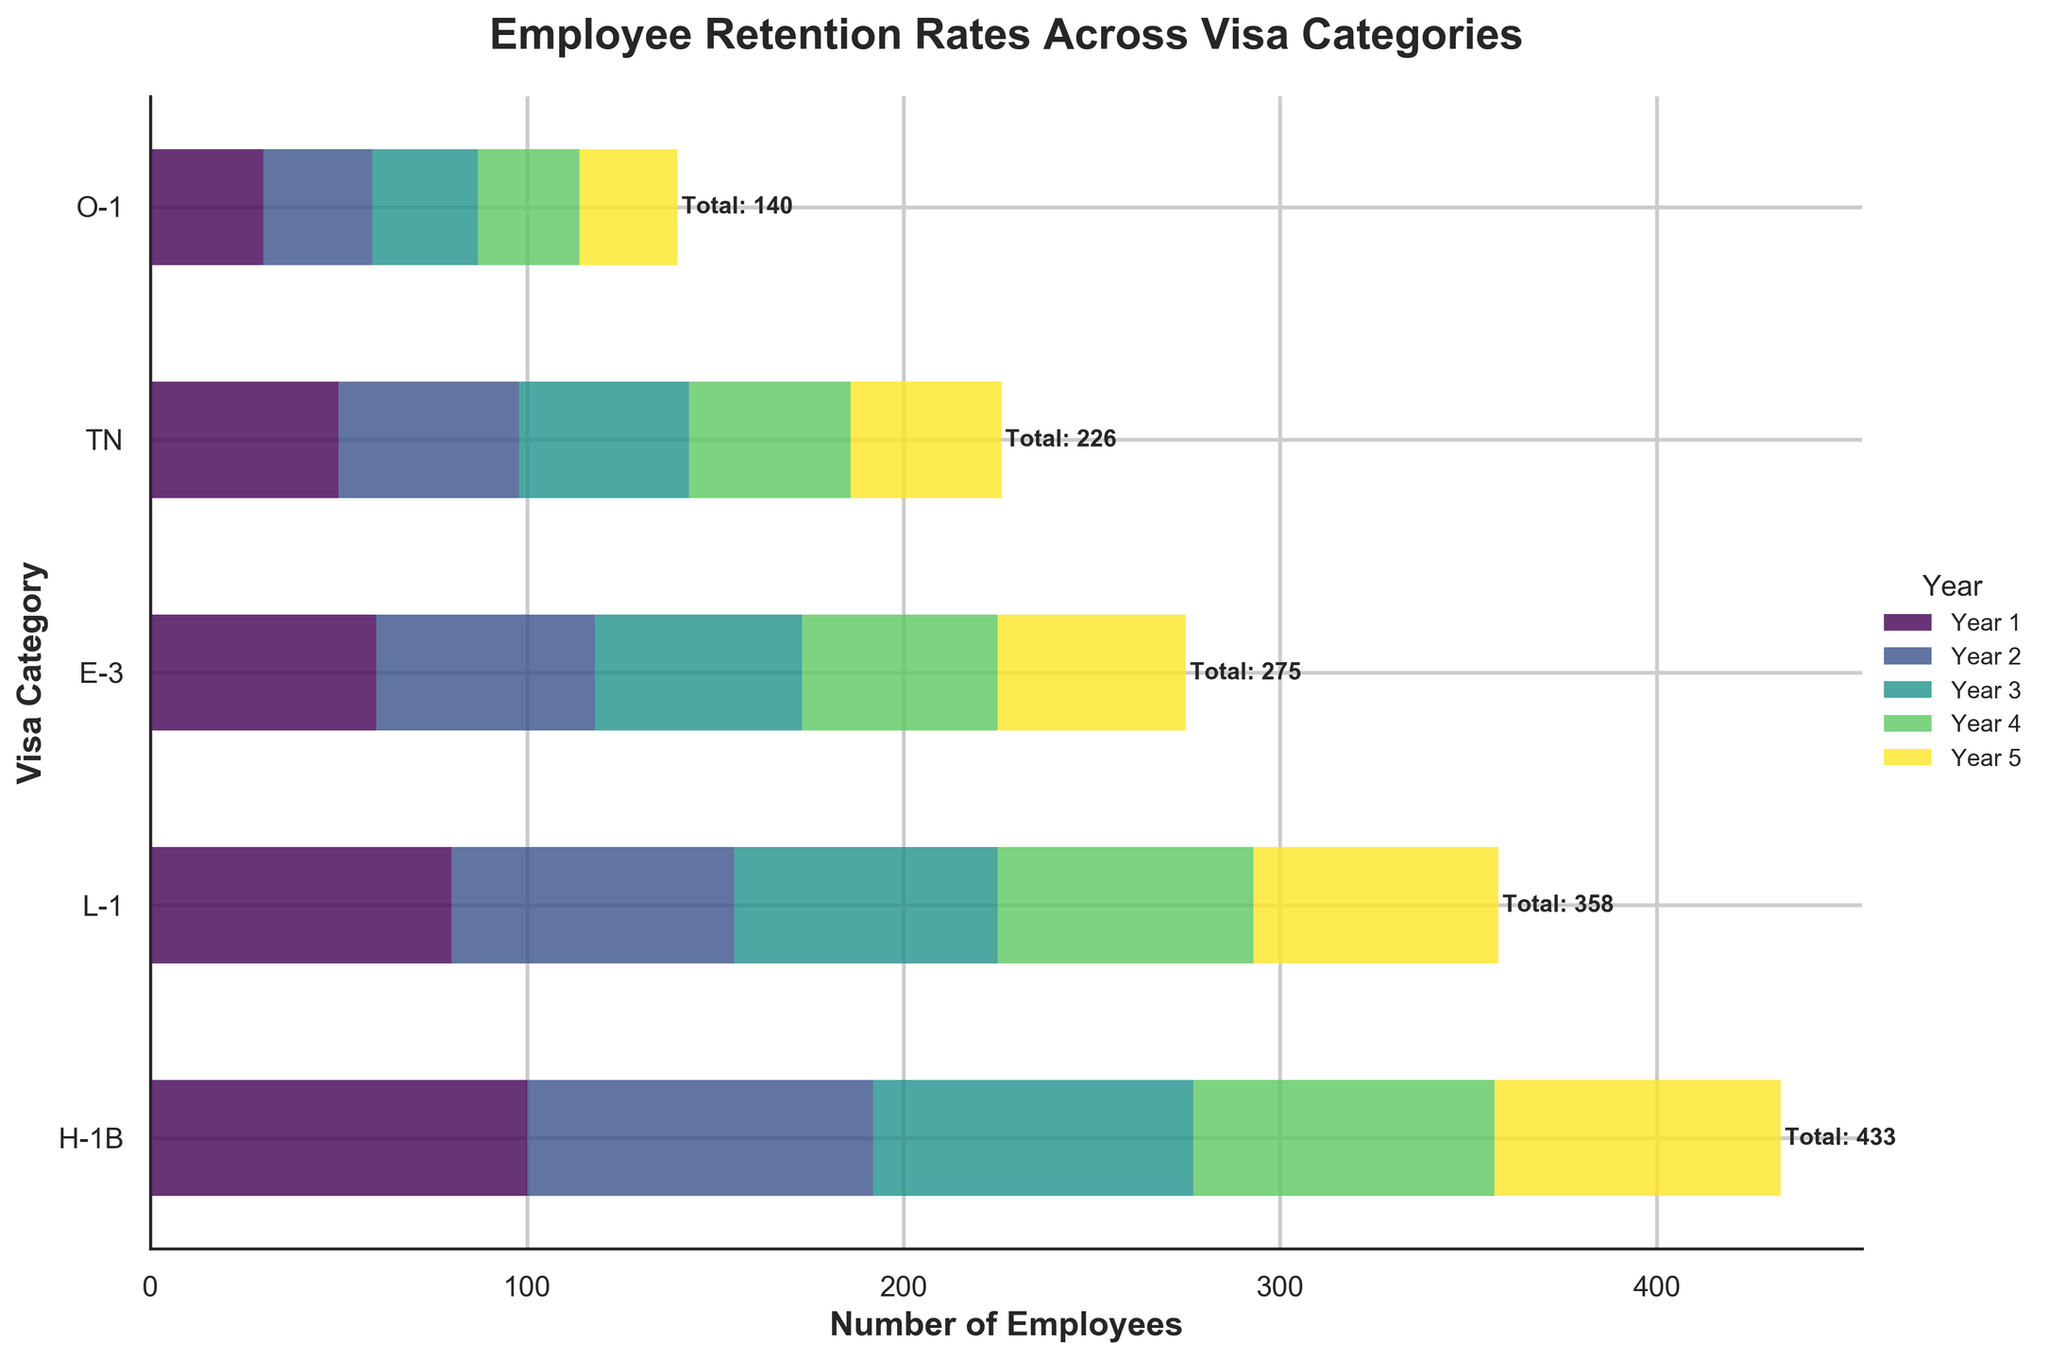What is the title of the figure? The title can be found at the top of the figure and provides information about the content being visualized.
Answer: Employee Retention Rates Across Visa Categories Which visa category had the highest number of employees in Year 1? Look at the first set of bars for Year 1 and identify the visa category with the longest bar.
Answer: H-1B What is the total number of employees for the TN visa category over 5 years? Sum the number of employees for TN across all 5 years: 50 + 48 + 45 + 43 + 40.
Answer: 226 How many more employees were retained in the H-1B category compared to the O-1 category by Year 5? Compare the values for H-1B and O-1 in Year 5: 76 (H-1B) - 26 (O-1).
Answer: 50 Which year shows the biggest decrease in employees for the L-1 category? Compare the differences between consecutive years for the L-1 category and identify the largest decrease: 80-75=5, 75-70=5, 70-68=2, 68-65=3.
Answer: Year 1 to Year 2 How does the retention rate trend for H-1B compare to E-3 over the 5 years? Observe the retention patterns for H-1B and E-3 over the years: H-1B has a consistent decrease, while E-3 also shows a consistent but less steep decline.
Answer: Both decline, H-1B more sharply What is the combined total number of employees in Year 3 across all visa categories? Add up the number of employees for each visa category in Year 3: 85 + 70 + 55 + 45 + 28.
Answer: 283 What percentage of the total employees in Year 2 does the L-1 visa category represent? Calculate the total number of employees in Year 2 and then the percentage for L-1: (75 / (92+75+58+48+29)) * 100.
Answer: 21.13% Which visa category has the smallest decrease in employee retention from Year 1 to Year 5? Determine the change from Year 1 to Year 5 for each category and find the smallest decrease: H-1B (100-76=24), L-1 (80-65=15), E-3 (60-50=10), TN (50-40=10), O-1 (30-26=4).
Answer: O-1 